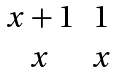<formula> <loc_0><loc_0><loc_500><loc_500>\begin{matrix} x + 1 & 1 \\ x & x \end{matrix}</formula> 